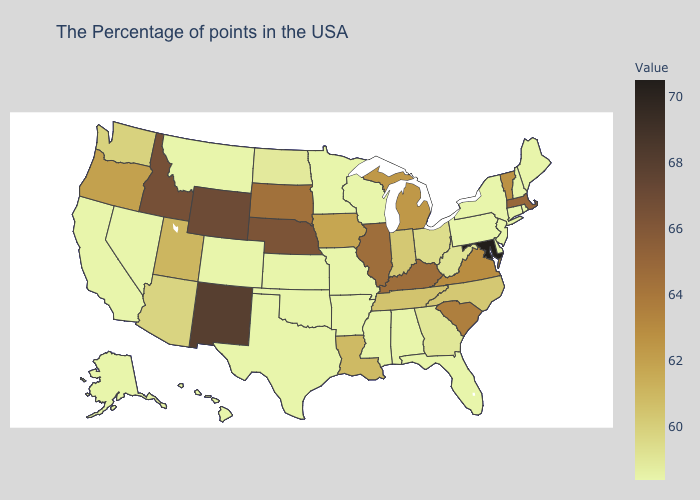Does the map have missing data?
Short answer required. No. Which states have the highest value in the USA?
Short answer required. Maryland. Does Louisiana have the highest value in the South?
Concise answer only. No. Which states have the lowest value in the South?
Keep it brief. Delaware, Florida, Alabama, Mississippi, Arkansas, Oklahoma, Texas. Does Mississippi have the highest value in the South?
Be succinct. No. Which states have the highest value in the USA?
Answer briefly. Maryland. Is the legend a continuous bar?
Concise answer only. Yes. 